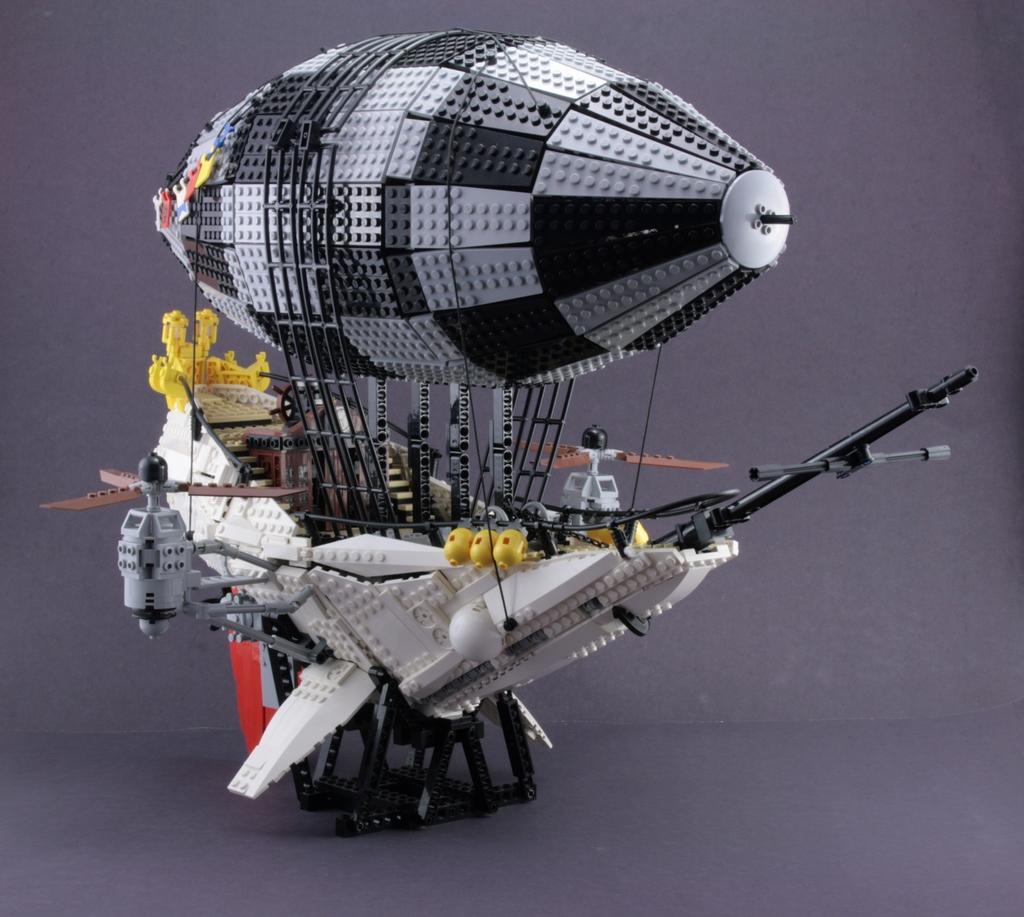How would you summarize this image in a sentence or two? In this picture I can see the violet color surface on which there is a Lego toy, which is of white, grey, black, red, brown and yellow in color. 